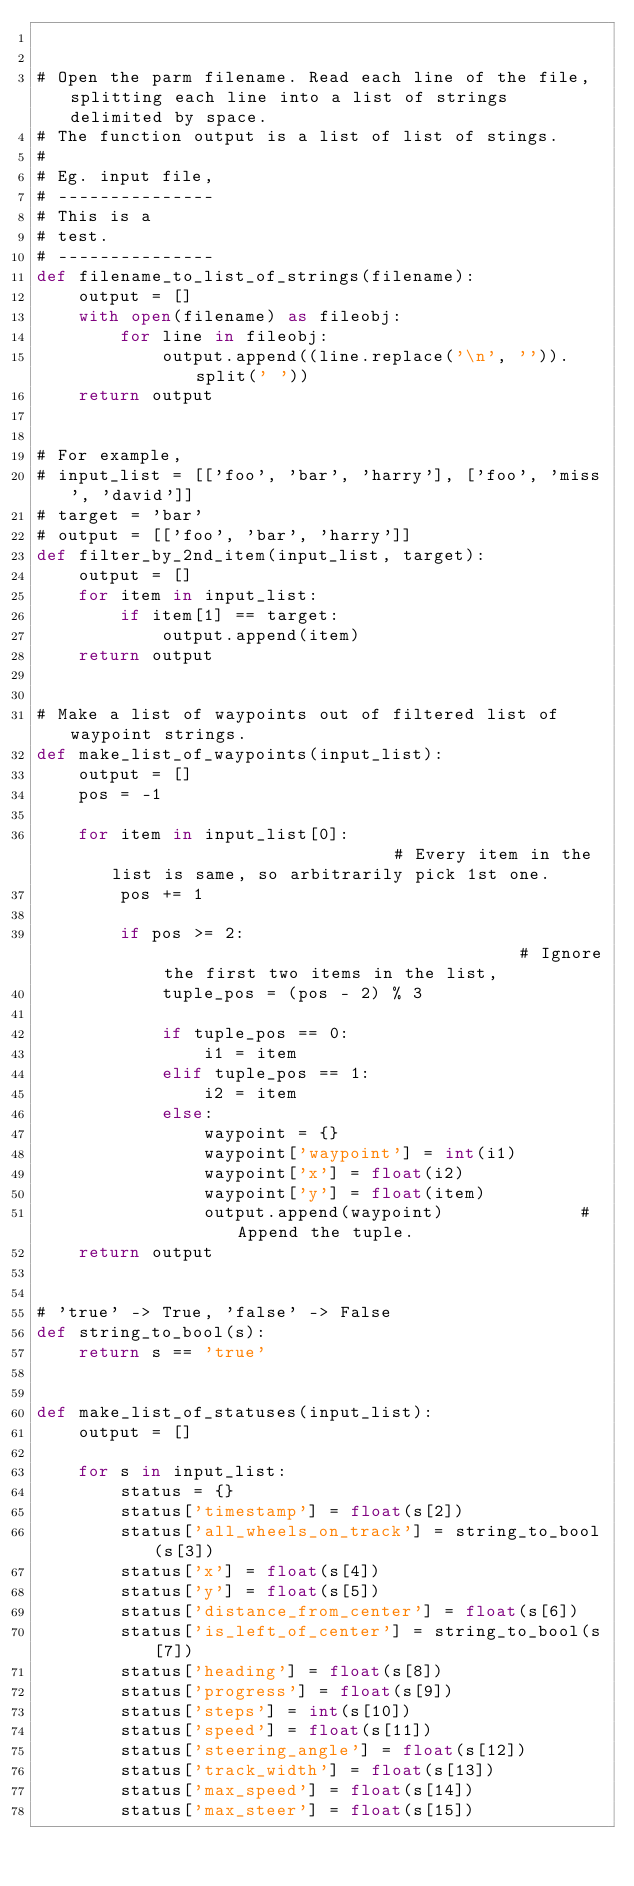<code> <loc_0><loc_0><loc_500><loc_500><_Python_>

# Open the parm filename. Read each line of the file, splitting each line into a list of strings delimited by space.
# The function output is a list of list of stings.
#
# Eg. input file,
# ---------------
# This is a
# test.
# ---------------
def filename_to_list_of_strings(filename):
    output = []
    with open(filename) as fileobj:
        for line in fileobj:
            output.append((line.replace('\n', '')).split(' '))
    return output


# For example,
# input_list = [['foo', 'bar', 'harry'], ['foo', 'miss', 'david']]
# target = 'bar'
# output = [['foo', 'bar', 'harry']]
def filter_by_2nd_item(input_list, target):
    output = []
    for item in input_list:
        if item[1] == target:
            output.append(item)
    return output


# Make a list of waypoints out of filtered list of waypoint strings.
def make_list_of_waypoints(input_list):
    output = []
    pos = -1

    for item in input_list[0]:                            # Every item in the list is same, so arbitrarily pick 1st one.
        pos += 1

        if pos >= 2:                                    # Ignore the first two items in the list,
            tuple_pos = (pos - 2) % 3

            if tuple_pos == 0:
                i1 = item
            elif tuple_pos == 1:
                i2 = item
            else:
                waypoint = {}
                waypoint['waypoint'] = int(i1)
                waypoint['x'] = float(i2)
                waypoint['y'] = float(item)
                output.append(waypoint)             # Append the tuple.
    return output


# 'true' -> True, 'false' -> False
def string_to_bool(s):
    return s == 'true'


def make_list_of_statuses(input_list):
    output = []

    for s in input_list:
        status = {}
        status['timestamp'] = float(s[2])
        status['all_wheels_on_track'] = string_to_bool(s[3])
        status['x'] = float(s[4])
        status['y'] = float(s[5])
        status['distance_from_center'] = float(s[6])
        status['is_left_of_center'] = string_to_bool(s[7])
        status['heading'] = float(s[8])
        status['progress'] = float(s[9])
        status['steps'] = int(s[10])
        status['speed'] = float(s[11])
        status['steering_angle'] = float(s[12])
        status['track_width'] = float(s[13])
        status['max_speed'] = float(s[14])
        status['max_steer'] = float(s[15])</code> 